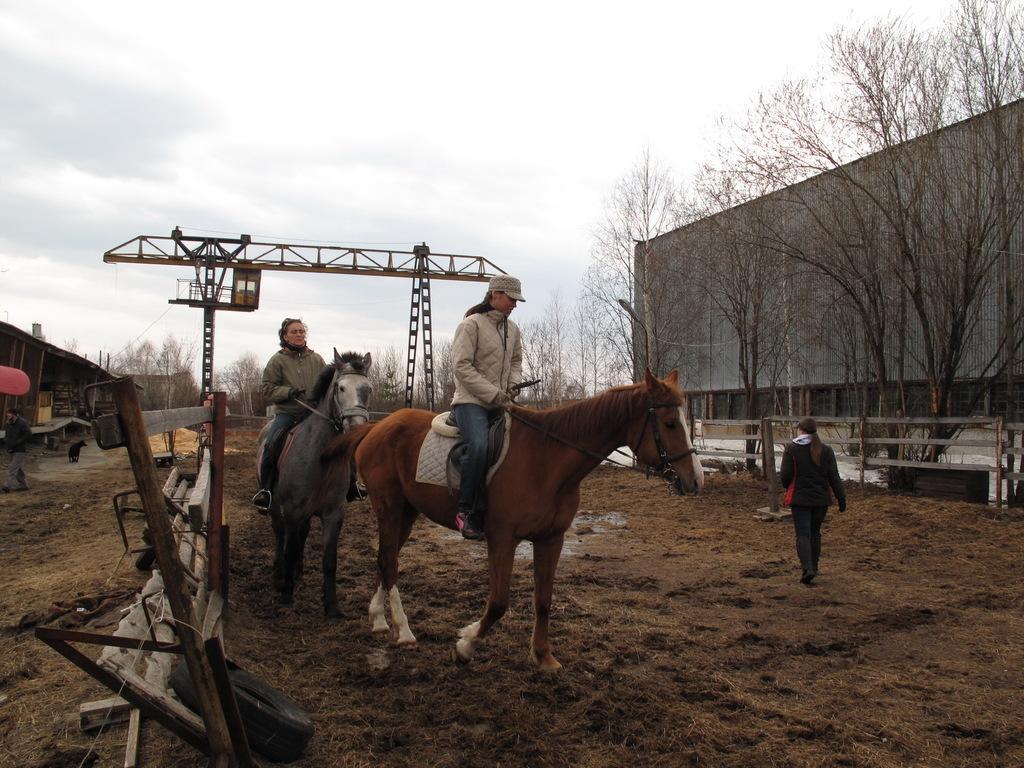How would you summarize this image in a sentence or two? In this image I can see three people. I can see the horses on the ground. On the left and right side, I can see the railing, trees and the buildings. In the background, I can see a metal pillar and clouds in the sky. 